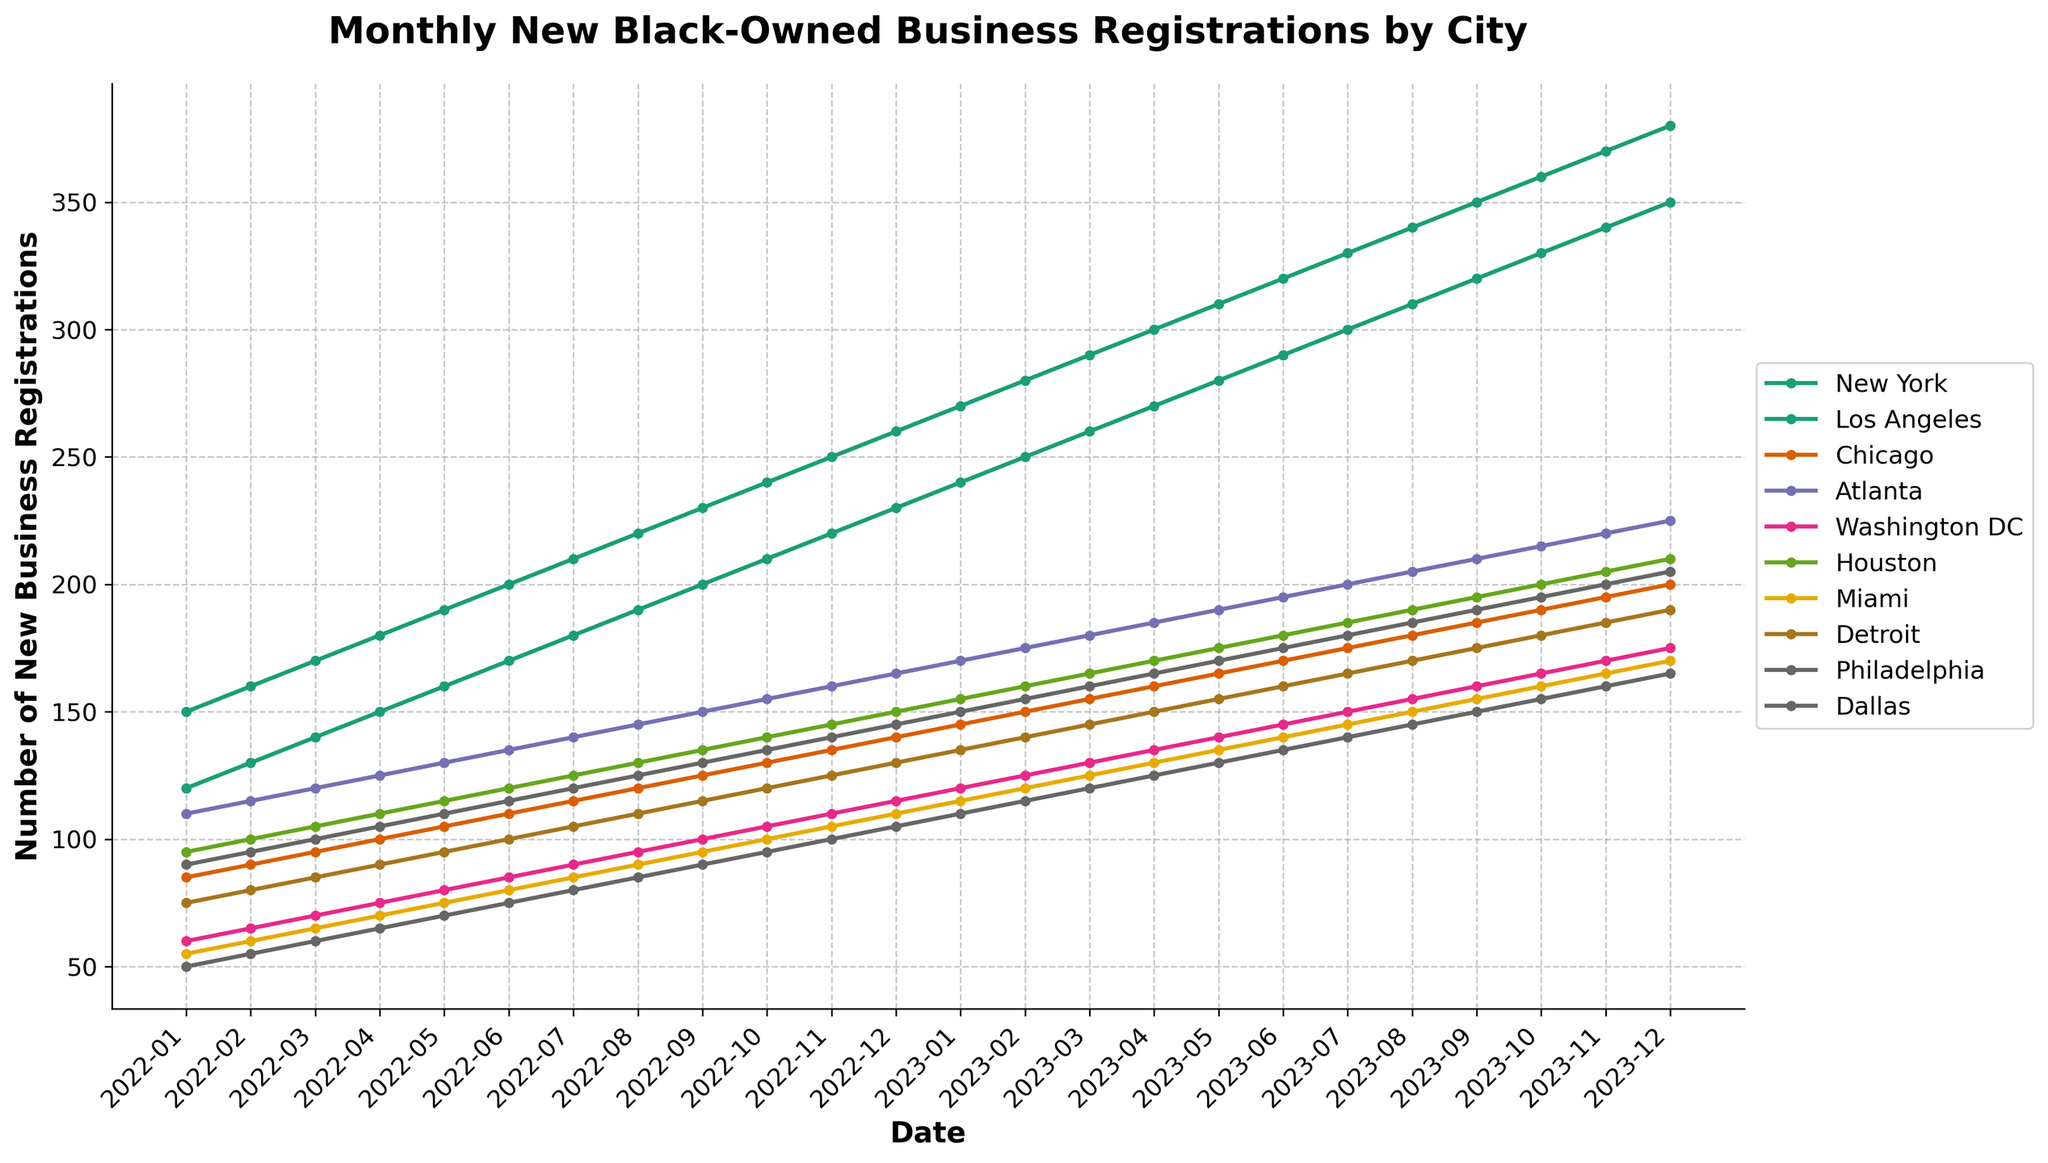What is the title of the figure? The title is prominently displayed at the top of the figure. It describes the content and context of the plot. The title of the figure is "Monthly New Black-Owned Business Registrations by City".
Answer: Monthly New Black-Owned Business Registrations by City What is the trend of new business registrations in New York from January 2022 to December 2023? To determine the trend, observe the line representing New York over the entire time period. The line shows an upward trajectory, indicating a consistent increase in new business registrations in New York from January 2022 to December 2023.
Answer: Increasing Which city had the highest number of new business registrations in December 2023? Look at the data points for December 2023 across all cities. The line reaches its highest value for New York, at 380 new business registrations.
Answer: New York Which two cities had the closest number of new business registrations in November 2023? Compare the data points for each city in November 2023. Washington DC and Houston had very close numbers, at 170 and 205 respectively, with a difference of only 5 registrations.
Answer: Washington DC and Houston What is the difference in new business registrations between Chicago and Miami in July 2023? Find the data points for Chicago and Miami in July 2023. Chicago has 175 registrations while Miami has 145. The difference is 175 - 145 = 30.
Answer: 30 Which city showed the most significant growth in new business registrations from January 2022 to December 2023? By comparing the starting and ending points of the lines, New York starts at 150 in January 2022 and ends at 380 in December 2023, showing the most significant growth of 230 registrations.
Answer: New York During which month did Atlanta surpass 200 new business registrations? Track the data points for Atlanta over time. Atlanta surpassed 200 registrations in June 2023.
Answer: June 2023 How does the trend in new business registrations in Los Angeles compare to that in Dallas? Observe the lines representing Los Angeles and Dallas. Both show an increasing trend, but Los Angeles has a more rapid increase compared to Dallas.
Answer: Los Angeles increased more rapidly What is the average number of new business registrations in Philadelphia over the entire period? Sum the data points for Philadelphia (90, 95, 100, 105, etc.) and divide by the number of points (24 months). (90+95+100+105+110+115+120+125+130+135+140+145+150+155+160+165+170+175+180+185+190+195+200+205)/24 = 147.5.
Answer: 147.5 In which month did Houston reach exactly 160 new business registrations? Look at the data for Houston month by month. Houston reached exactly 160 registrations in February 2023.
Answer: February 2023 How many total new business registrations did Detroit have from January 2022 to December 2023? Sum the data points for Detroit. 75+80+85+90+95+100+105+110+115+120+125+130+135+140+145+150+155+160+165+170+175+180+185+190 = 3190.
Answer: 3190 